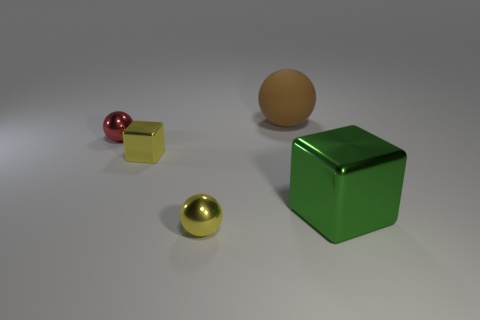Is there anything else that is made of the same material as the large brown object?
Provide a short and direct response. No. Is the tiny block the same color as the large sphere?
Your answer should be very brief. No. Are there any other things that are the same shape as the red shiny object?
Provide a short and direct response. Yes. Is the number of yellow objects less than the number of big gray metallic balls?
Your response must be concise. No. What color is the big thing that is in front of the ball that is on the right side of the yellow metallic sphere?
Ensure brevity in your answer.  Green. What is the yellow object that is to the left of the tiny ball that is right of the cube that is on the left side of the brown matte thing made of?
Keep it short and to the point. Metal. Do the green cube right of the yellow metallic sphere and the small red ball have the same size?
Your answer should be very brief. No. What is the material of the block that is in front of the small yellow block?
Your response must be concise. Metal. Is the number of metal cubes greater than the number of spheres?
Make the answer very short. No. How many objects are either small red metallic things left of the big green block or blue objects?
Make the answer very short. 1. 